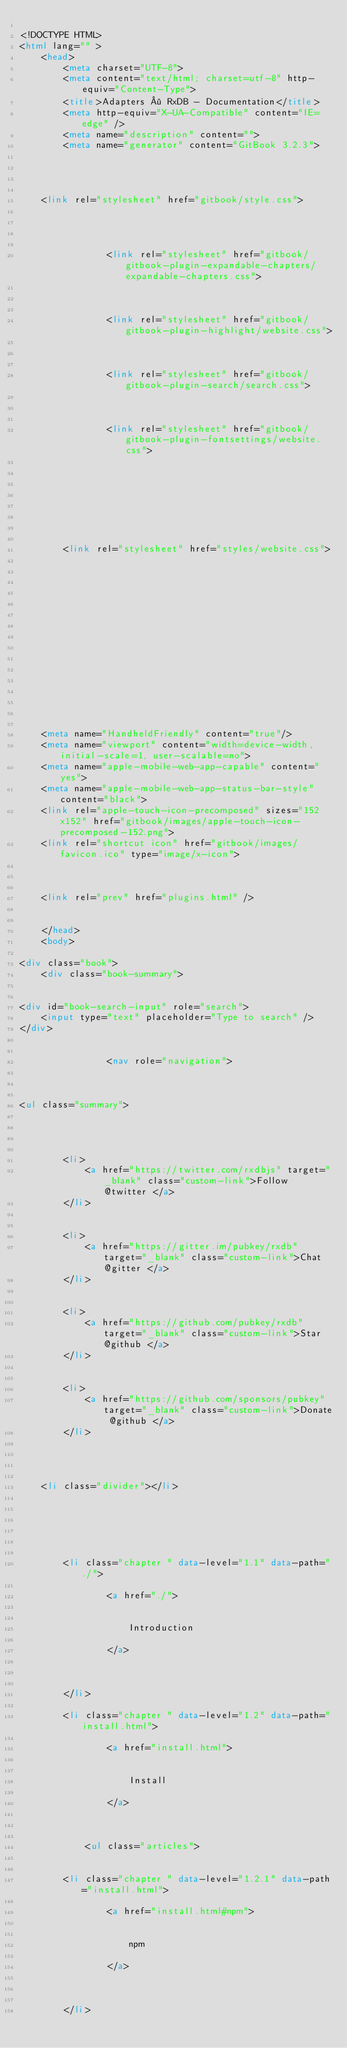Convert code to text. <code><loc_0><loc_0><loc_500><loc_500><_HTML_>
<!DOCTYPE HTML>
<html lang="" >
    <head>
        <meta charset="UTF-8">
        <meta content="text/html; charset=utf-8" http-equiv="Content-Type">
        <title>Adapters · RxDB - Documentation</title>
        <meta http-equiv="X-UA-Compatible" content="IE=edge" />
        <meta name="description" content="">
        <meta name="generator" content="GitBook 3.2.3">
        
        
        
    
    <link rel="stylesheet" href="gitbook/style.css">

    
            
                
                <link rel="stylesheet" href="gitbook/gitbook-plugin-expandable-chapters/expandable-chapters.css">
                
            
                
                <link rel="stylesheet" href="gitbook/gitbook-plugin-highlight/website.css">
                
            
                
                <link rel="stylesheet" href="gitbook/gitbook-plugin-search/search.css">
                
            
                
                <link rel="stylesheet" href="gitbook/gitbook-plugin-fontsettings/website.css">
                
            
        

    

    
        
        <link rel="stylesheet" href="styles/website.css">
        
    
        
    
        
    
        
    
        
    
        
    

        
    
    
    <meta name="HandheldFriendly" content="true"/>
    <meta name="viewport" content="width=device-width, initial-scale=1, user-scalable=no">
    <meta name="apple-mobile-web-app-capable" content="yes">
    <meta name="apple-mobile-web-app-status-bar-style" content="black">
    <link rel="apple-touch-icon-precomposed" sizes="152x152" href="gitbook/images/apple-touch-icon-precomposed-152.png">
    <link rel="shortcut icon" href="gitbook/images/favicon.ico" type="image/x-icon">

    
    
    <link rel="prev" href="plugins.html" />
    

    </head>
    <body>
        
<div class="book">
    <div class="book-summary">
        
            
<div id="book-search-input" role="search">
    <input type="text" placeholder="Type to search" />
</div>

            
                <nav role="navigation">
                


<ul class="summary">
    
    
    
        
        <li>
            <a href="https://twitter.com/rxdbjs" target="_blank" class="custom-link">Follow @twitter </a>
        </li>
    
        
        <li>
            <a href="https://gitter.im/pubkey/rxdb" target="_blank" class="custom-link">Chat @gitter </a>
        </li>
    
        
        <li>
            <a href="https://github.com/pubkey/rxdb" target="_blank" class="custom-link">Star @github </a>
        </li>
    
        
        <li>
            <a href="https://github.com/sponsors/pubkey" target="_blank" class="custom-link">Donate @github </a>
        </li>
    
    

    
    <li class="divider"></li>
    

    
        
        
    
        <li class="chapter " data-level="1.1" data-path="./">
            
                <a href="./">
            
                    
                    Introduction
            
                </a>
            

            
        </li>
    
        <li class="chapter " data-level="1.2" data-path="install.html">
            
                <a href="install.html">
            
                    
                    Install
            
                </a>
            

            
            <ul class="articles">
                
    
        <li class="chapter " data-level="1.2.1" data-path="install.html">
            
                <a href="install.html#npm">
            
                    
                    npm
            
                </a>
            

            
        </li>
    </code> 